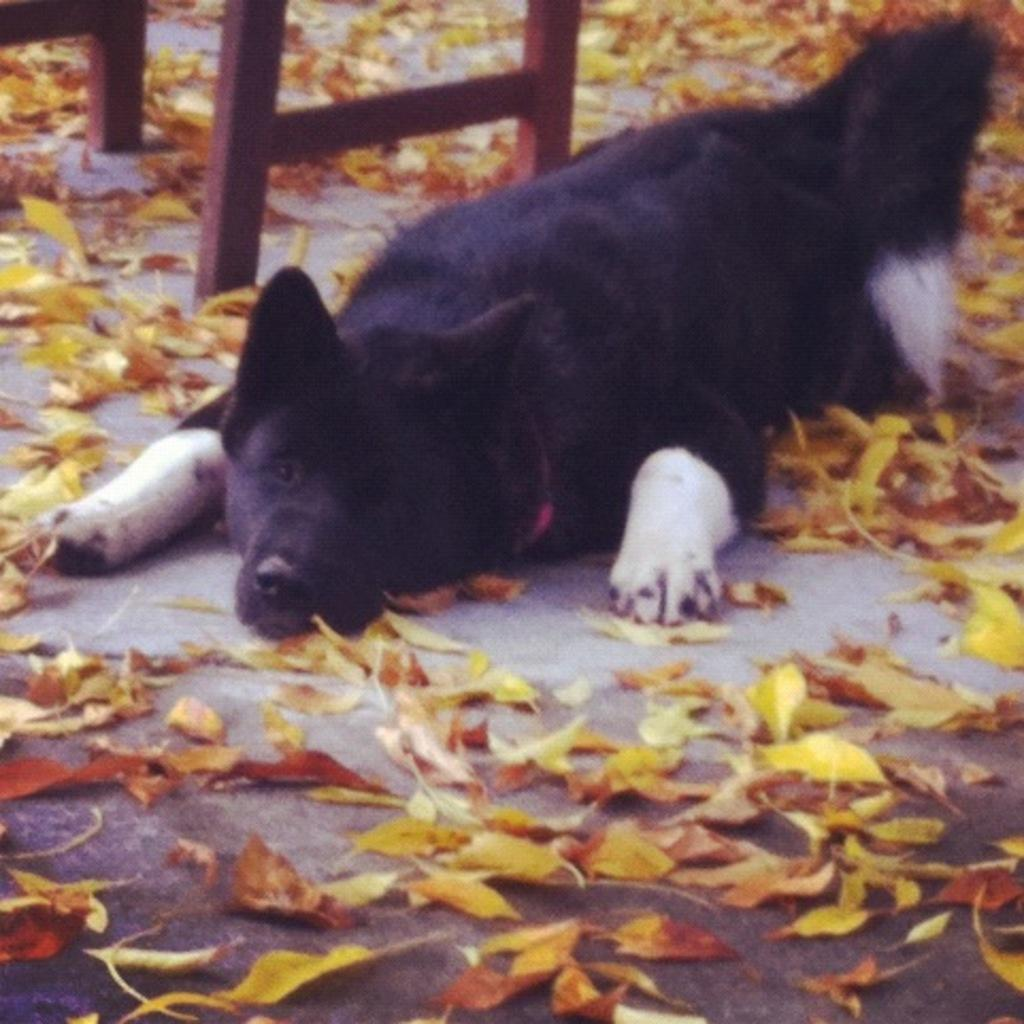What type of animal can be seen in the image? There is a dog in the image. What is the dog doing in the image? The dog is lying on the ground. What type of natural debris is visible in the image? There are dried leaves visible in the image. What part of a piece of furniture is present in the image? The legs of a table are present in the image. What type of coastline can be seen in the image? There is no coastline present in the image; it features a dog lying on the ground with dried leaves and table legs visible. 